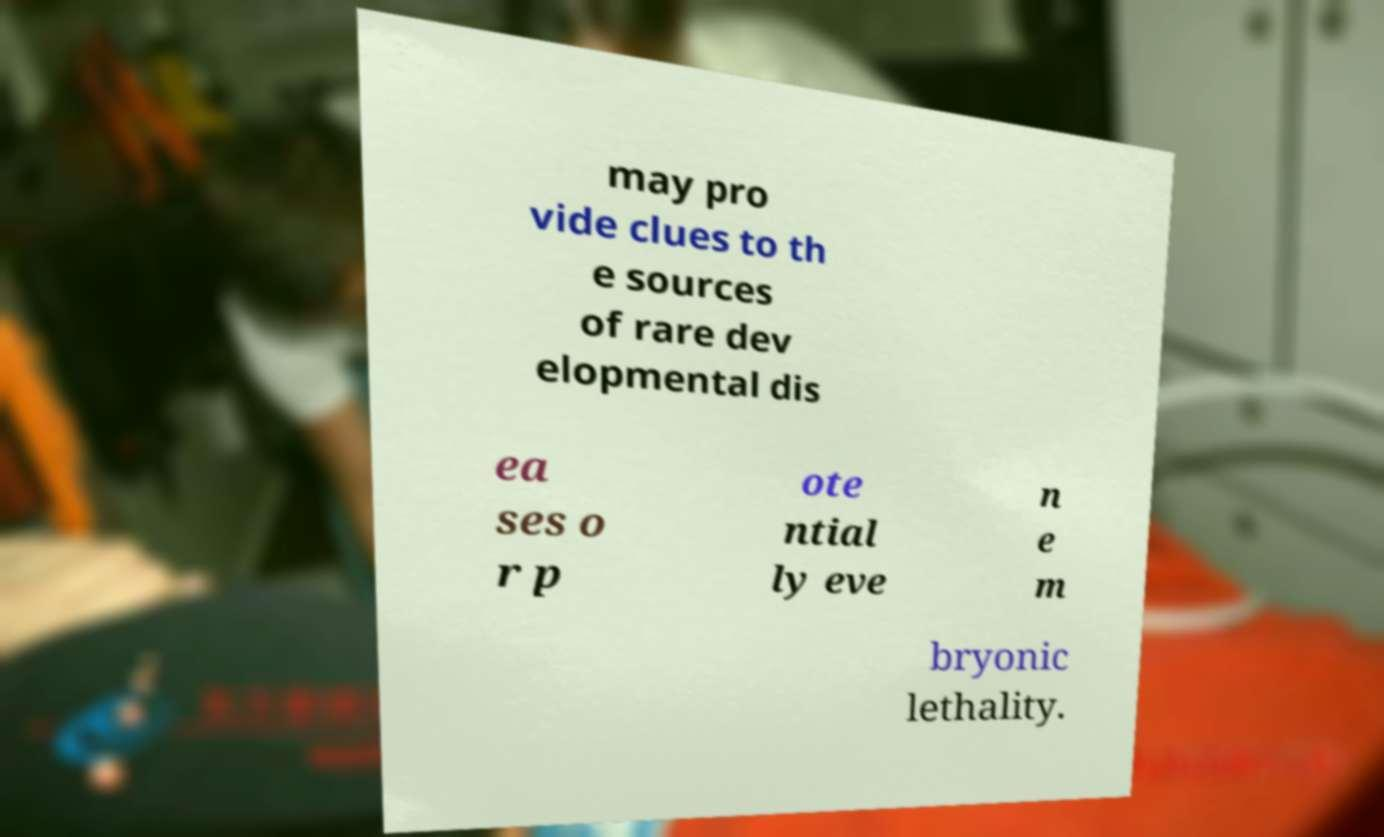Please identify and transcribe the text found in this image. may pro vide clues to th e sources of rare dev elopmental dis ea ses o r p ote ntial ly eve n e m bryonic lethality. 